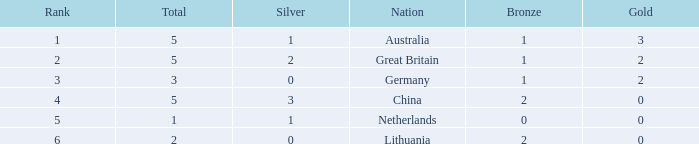What is the typical standing when there are 2 bronze, the overall count is 2, and gold is under 0? None. Could you help me parse every detail presented in this table? {'header': ['Rank', 'Total', 'Silver', 'Nation', 'Bronze', 'Gold'], 'rows': [['1', '5', '1', 'Australia', '1', '3'], ['2', '5', '2', 'Great Britain', '1', '2'], ['3', '3', '0', 'Germany', '1', '2'], ['4', '5', '3', 'China', '2', '0'], ['5', '1', '1', 'Netherlands', '0', '0'], ['6', '2', '0', 'Lithuania', '2', '0']]} 